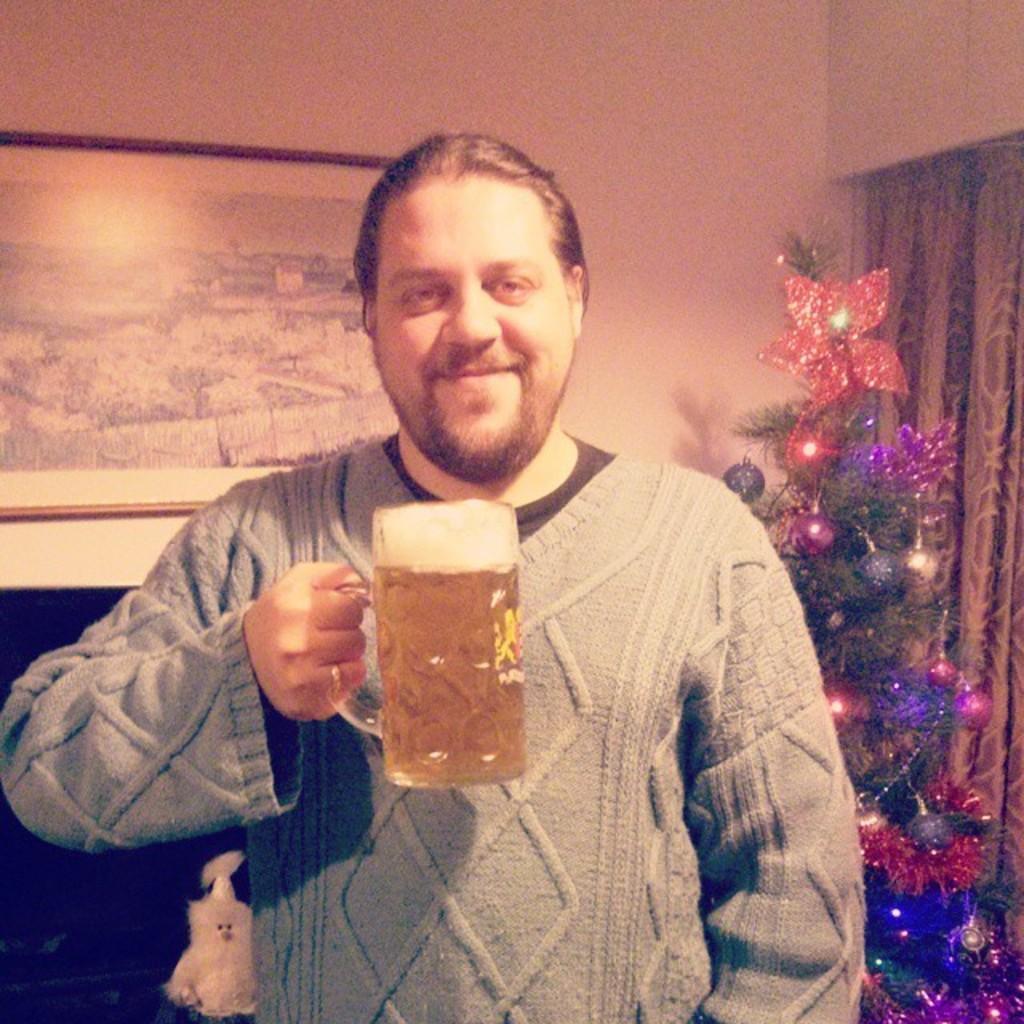Please provide a concise description of this image. In this image the man is holding a glass. At the back side we can see a Christmas tree and the frame is attached to the wall and there is a curtain. 